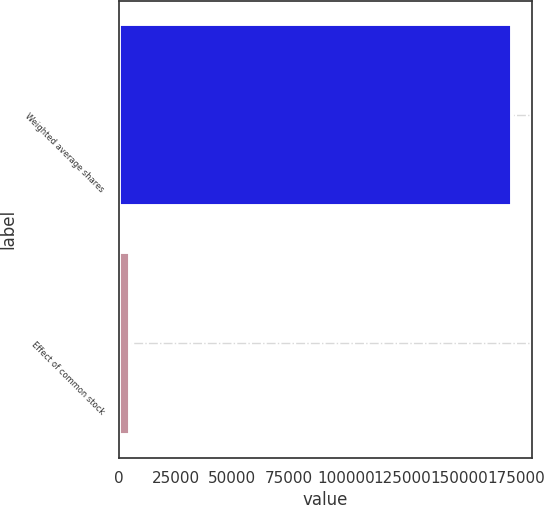Convert chart. <chart><loc_0><loc_0><loc_500><loc_500><bar_chart><fcel>Weighted average shares<fcel>Effect of common stock<nl><fcel>173341<fcel>4976<nl></chart> 